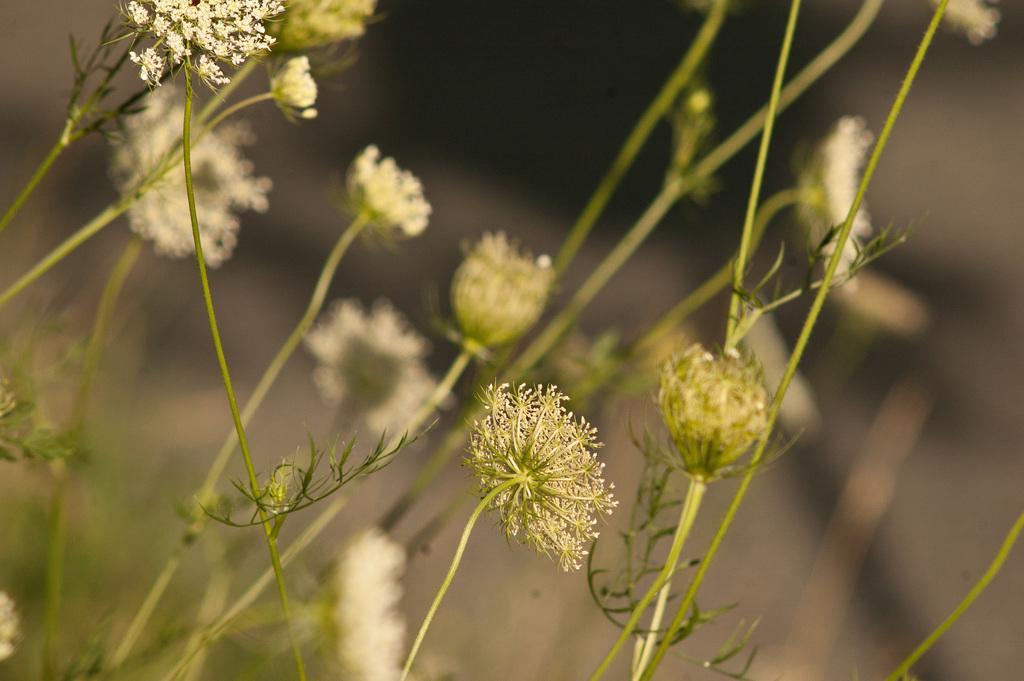Describe this image in one or two sentences. In this image I can see flowering plants. This image is taken may be in a farm. 